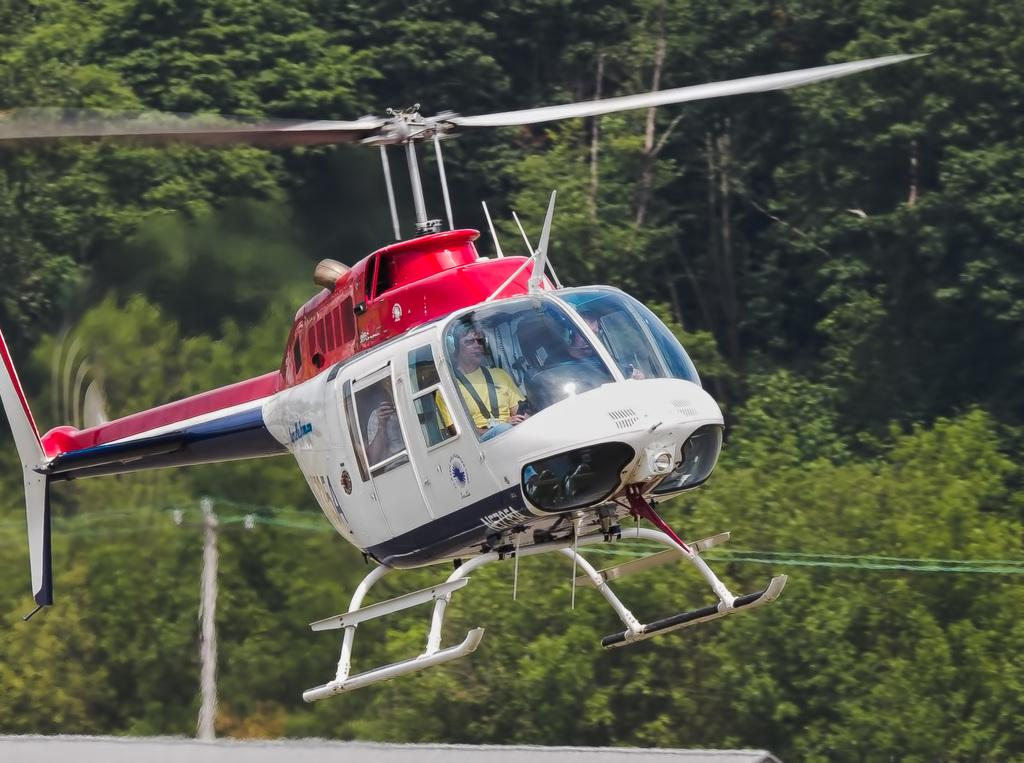What is the main subject of the picture? The main subject of the picture is a helicopter. What else can be seen in the picture besides the helicopter? There is a pole and trees visible in the picture. Are there any people in the helicopter? Yes, there are people seated in the helicopter. What type of quill is being used by the friends in the helicopter? There are no friends or quills present in the image; it features a helicopter with people inside. 